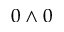Convert formula to latex. <formula><loc_0><loc_0><loc_500><loc_500>0 \wedge 0</formula> 